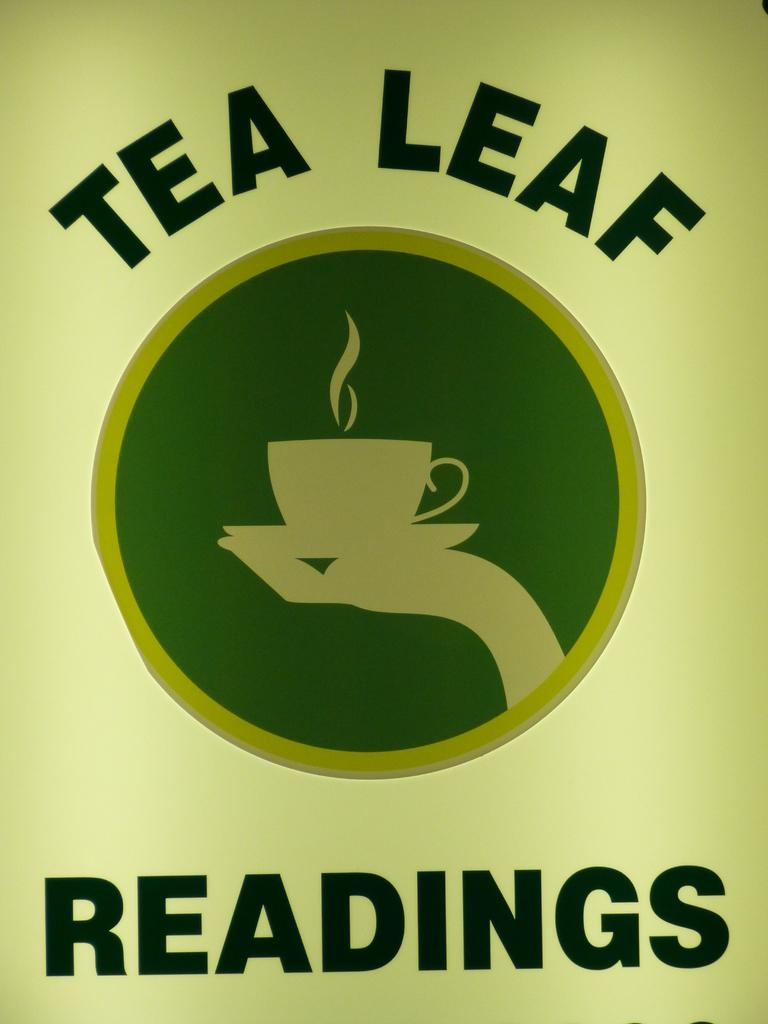What is present on the poster in the image? There is a poster in the image. What is featured on the poster besides the writing? The poster has a logo. What type of information is present on the poster? There is writing on the poster. What shape is the beginner route on the poster? There is no beginner route or shape mentioned on the poster; it only has a logo and writing. 